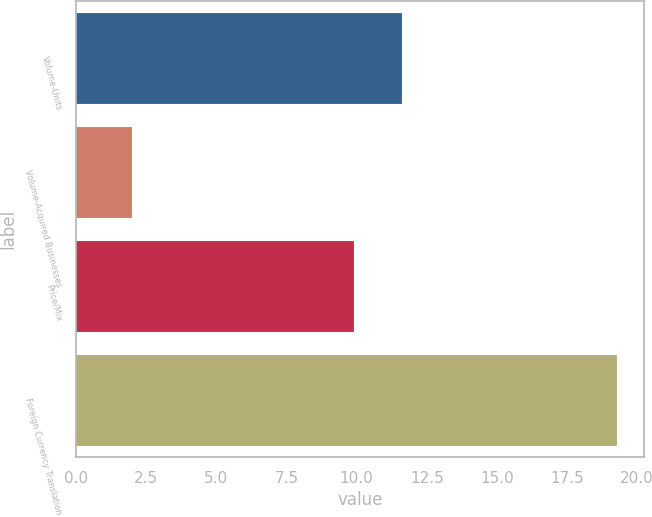<chart> <loc_0><loc_0><loc_500><loc_500><bar_chart><fcel>Volume-Units<fcel>Volume-Acquired Businesses<fcel>Price/Mix<fcel>Foreign Currency Translation<nl><fcel>11.63<fcel>2<fcel>9.9<fcel>19.3<nl></chart> 